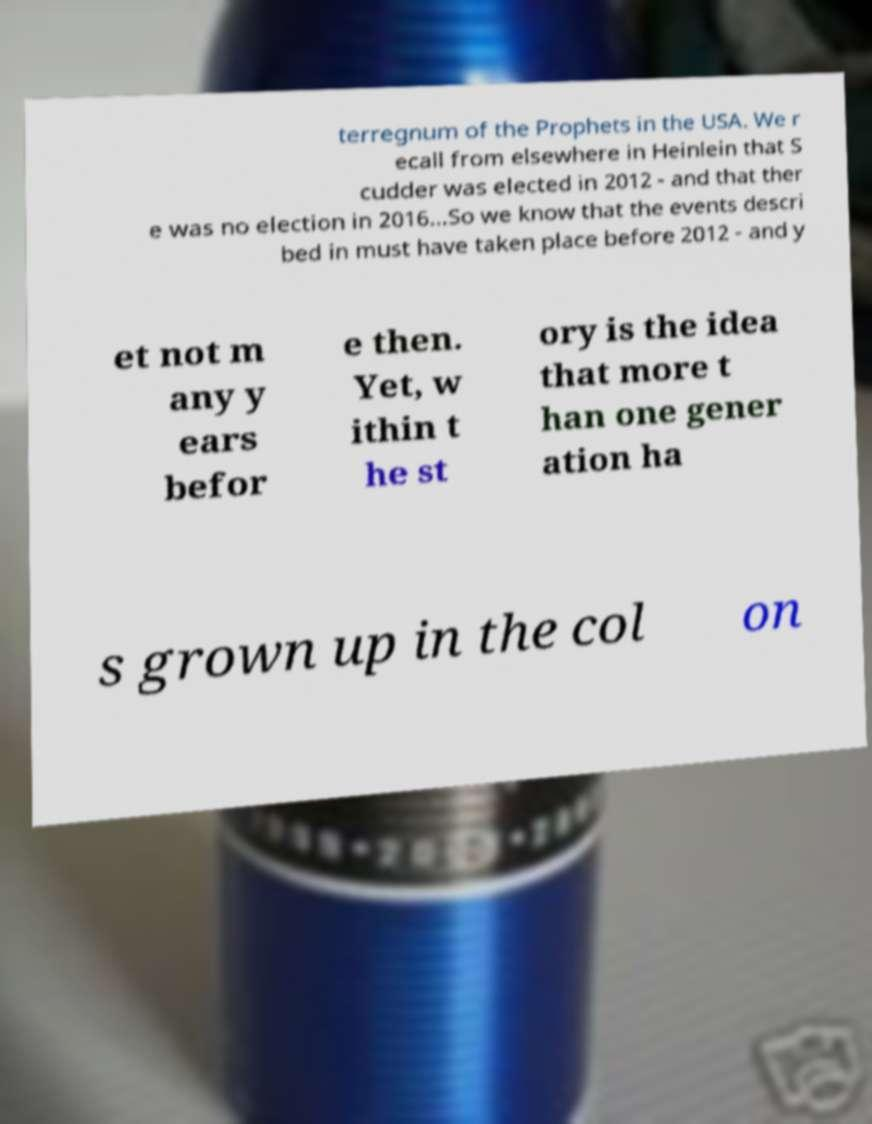Could you extract and type out the text from this image? terregnum of the Prophets in the USA. We r ecall from elsewhere in Heinlein that S cudder was elected in 2012 - and that ther e was no election in 2016...So we know that the events descri bed in must have taken place before 2012 - and y et not m any y ears befor e then. Yet, w ithin t he st ory is the idea that more t han one gener ation ha s grown up in the col on 